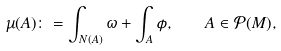Convert formula to latex. <formula><loc_0><loc_0><loc_500><loc_500>\mu ( A ) \colon = \int _ { N ( A ) } \omega + \int _ { A } \phi , \quad A \in \mathcal { P } ( M ) ,</formula> 